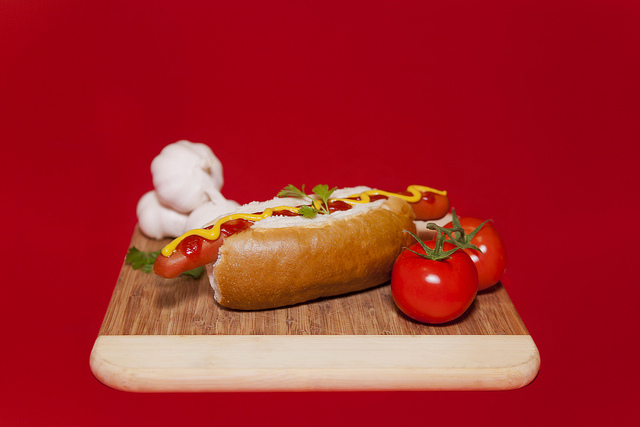What meal is this for? This is most likely prepared for lunch, given its simple yet satisfying appearance. 